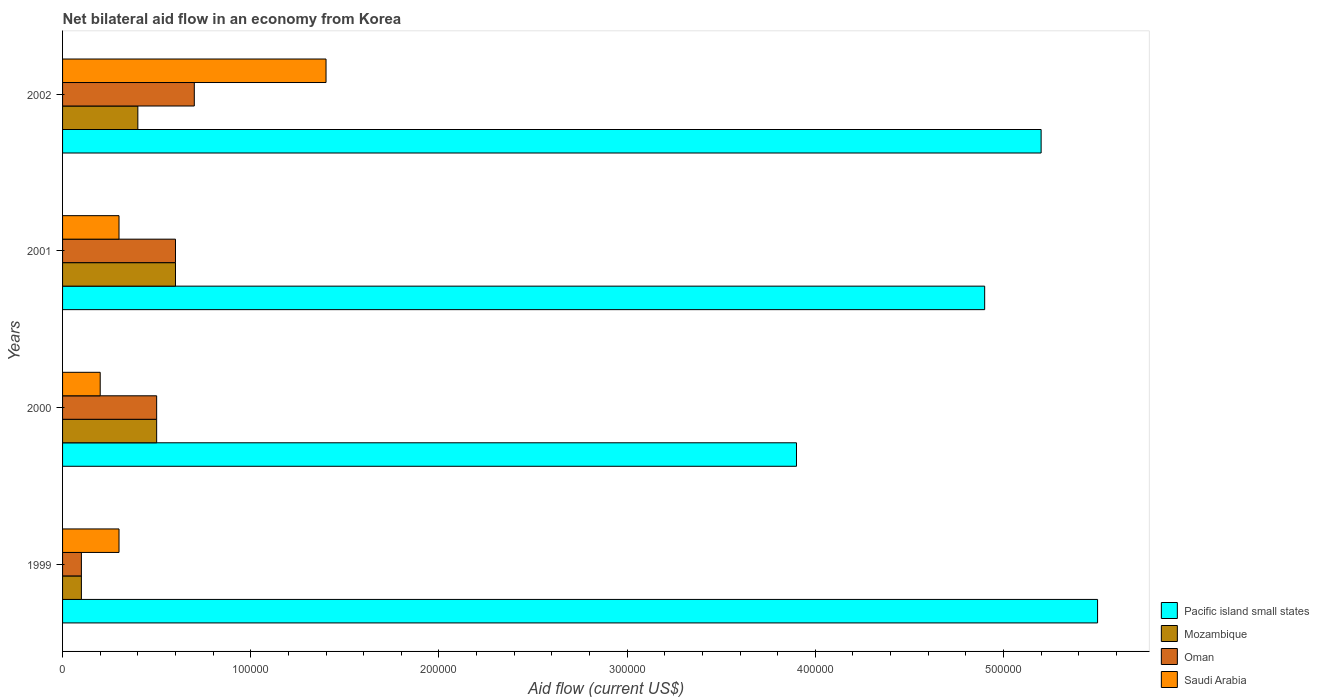How many different coloured bars are there?
Give a very brief answer. 4. How many groups of bars are there?
Provide a short and direct response. 4. In how many cases, is the number of bars for a given year not equal to the number of legend labels?
Offer a very short reply. 0. What is the net bilateral aid flow in Mozambique in 2001?
Make the answer very short. 6.00e+04. Across all years, what is the minimum net bilateral aid flow in Mozambique?
Make the answer very short. 10000. In which year was the net bilateral aid flow in Oman maximum?
Keep it short and to the point. 2002. What is the total net bilateral aid flow in Pacific island small states in the graph?
Your answer should be compact. 1.95e+06. What is the difference between the net bilateral aid flow in Mozambique in 1999 and that in 2001?
Make the answer very short. -5.00e+04. What is the average net bilateral aid flow in Pacific island small states per year?
Offer a very short reply. 4.88e+05. What is the ratio of the net bilateral aid flow in Oman in 1999 to that in 2002?
Your answer should be compact. 0.14. Is the difference between the net bilateral aid flow in Saudi Arabia in 1999 and 2000 greater than the difference between the net bilateral aid flow in Oman in 1999 and 2000?
Ensure brevity in your answer.  Yes. What is the difference between the highest and the lowest net bilateral aid flow in Saudi Arabia?
Keep it short and to the point. 1.20e+05. Is the sum of the net bilateral aid flow in Mozambique in 2000 and 2001 greater than the maximum net bilateral aid flow in Saudi Arabia across all years?
Your answer should be compact. No. Is it the case that in every year, the sum of the net bilateral aid flow in Saudi Arabia and net bilateral aid flow in Mozambique is greater than the sum of net bilateral aid flow in Pacific island small states and net bilateral aid flow in Oman?
Ensure brevity in your answer.  No. What does the 1st bar from the top in 1999 represents?
Provide a short and direct response. Saudi Arabia. What does the 3rd bar from the bottom in 2000 represents?
Give a very brief answer. Oman. How many bars are there?
Provide a short and direct response. 16. Are the values on the major ticks of X-axis written in scientific E-notation?
Provide a succinct answer. No. Where does the legend appear in the graph?
Give a very brief answer. Bottom right. What is the title of the graph?
Your response must be concise. Net bilateral aid flow in an economy from Korea. Does "Guyana" appear as one of the legend labels in the graph?
Offer a terse response. No. What is the label or title of the X-axis?
Make the answer very short. Aid flow (current US$). What is the Aid flow (current US$) of Oman in 2000?
Keep it short and to the point. 5.00e+04. What is the Aid flow (current US$) of Mozambique in 2001?
Give a very brief answer. 6.00e+04. What is the Aid flow (current US$) of Pacific island small states in 2002?
Offer a terse response. 5.20e+05. What is the Aid flow (current US$) in Mozambique in 2002?
Keep it short and to the point. 4.00e+04. What is the Aid flow (current US$) in Oman in 2002?
Provide a short and direct response. 7.00e+04. What is the Aid flow (current US$) of Saudi Arabia in 2002?
Provide a short and direct response. 1.40e+05. Across all years, what is the maximum Aid flow (current US$) in Mozambique?
Keep it short and to the point. 6.00e+04. Across all years, what is the maximum Aid flow (current US$) in Saudi Arabia?
Give a very brief answer. 1.40e+05. Across all years, what is the minimum Aid flow (current US$) in Mozambique?
Provide a short and direct response. 10000. What is the total Aid flow (current US$) of Pacific island small states in the graph?
Give a very brief answer. 1.95e+06. What is the difference between the Aid flow (current US$) of Pacific island small states in 1999 and that in 2000?
Provide a succinct answer. 1.60e+05. What is the difference between the Aid flow (current US$) of Oman in 1999 and that in 2000?
Offer a very short reply. -4.00e+04. What is the difference between the Aid flow (current US$) in Saudi Arabia in 1999 and that in 2000?
Provide a succinct answer. 10000. What is the difference between the Aid flow (current US$) of Pacific island small states in 1999 and that in 2001?
Offer a terse response. 6.00e+04. What is the difference between the Aid flow (current US$) in Mozambique in 1999 and that in 2001?
Your answer should be very brief. -5.00e+04. What is the difference between the Aid flow (current US$) in Oman in 1999 and that in 2001?
Ensure brevity in your answer.  -5.00e+04. What is the difference between the Aid flow (current US$) of Saudi Arabia in 1999 and that in 2001?
Keep it short and to the point. 0. What is the difference between the Aid flow (current US$) in Oman in 1999 and that in 2002?
Your answer should be compact. -6.00e+04. What is the difference between the Aid flow (current US$) of Pacific island small states in 2000 and that in 2001?
Your response must be concise. -1.00e+05. What is the difference between the Aid flow (current US$) of Oman in 2000 and that in 2001?
Offer a very short reply. -10000. What is the difference between the Aid flow (current US$) in Saudi Arabia in 2000 and that in 2001?
Offer a terse response. -10000. What is the difference between the Aid flow (current US$) of Pacific island small states in 2000 and that in 2002?
Your response must be concise. -1.30e+05. What is the difference between the Aid flow (current US$) of Mozambique in 2000 and that in 2002?
Provide a short and direct response. 10000. What is the difference between the Aid flow (current US$) of Oman in 2000 and that in 2002?
Keep it short and to the point. -2.00e+04. What is the difference between the Aid flow (current US$) in Pacific island small states in 2001 and that in 2002?
Ensure brevity in your answer.  -3.00e+04. What is the difference between the Aid flow (current US$) in Mozambique in 2001 and that in 2002?
Offer a terse response. 2.00e+04. What is the difference between the Aid flow (current US$) in Saudi Arabia in 2001 and that in 2002?
Offer a terse response. -1.10e+05. What is the difference between the Aid flow (current US$) in Pacific island small states in 1999 and the Aid flow (current US$) in Mozambique in 2000?
Keep it short and to the point. 5.00e+05. What is the difference between the Aid flow (current US$) of Pacific island small states in 1999 and the Aid flow (current US$) of Oman in 2000?
Your answer should be compact. 5.00e+05. What is the difference between the Aid flow (current US$) in Pacific island small states in 1999 and the Aid flow (current US$) in Saudi Arabia in 2000?
Provide a succinct answer. 5.30e+05. What is the difference between the Aid flow (current US$) of Mozambique in 1999 and the Aid flow (current US$) of Saudi Arabia in 2000?
Keep it short and to the point. -10000. What is the difference between the Aid flow (current US$) of Pacific island small states in 1999 and the Aid flow (current US$) of Mozambique in 2001?
Offer a terse response. 4.90e+05. What is the difference between the Aid flow (current US$) of Pacific island small states in 1999 and the Aid flow (current US$) of Saudi Arabia in 2001?
Keep it short and to the point. 5.20e+05. What is the difference between the Aid flow (current US$) of Pacific island small states in 1999 and the Aid flow (current US$) of Mozambique in 2002?
Your answer should be compact. 5.10e+05. What is the difference between the Aid flow (current US$) of Mozambique in 1999 and the Aid flow (current US$) of Saudi Arabia in 2002?
Offer a very short reply. -1.30e+05. What is the difference between the Aid flow (current US$) in Oman in 1999 and the Aid flow (current US$) in Saudi Arabia in 2002?
Make the answer very short. -1.30e+05. What is the difference between the Aid flow (current US$) of Pacific island small states in 2000 and the Aid flow (current US$) of Mozambique in 2001?
Offer a terse response. 3.30e+05. What is the difference between the Aid flow (current US$) in Pacific island small states in 2000 and the Aid flow (current US$) in Saudi Arabia in 2001?
Give a very brief answer. 3.60e+05. What is the difference between the Aid flow (current US$) in Pacific island small states in 2000 and the Aid flow (current US$) in Oman in 2002?
Your response must be concise. 3.20e+05. What is the difference between the Aid flow (current US$) in Mozambique in 2000 and the Aid flow (current US$) in Oman in 2002?
Offer a terse response. -2.00e+04. What is the difference between the Aid flow (current US$) in Mozambique in 2000 and the Aid flow (current US$) in Saudi Arabia in 2002?
Offer a terse response. -9.00e+04. What is the difference between the Aid flow (current US$) of Oman in 2000 and the Aid flow (current US$) of Saudi Arabia in 2002?
Offer a terse response. -9.00e+04. What is the difference between the Aid flow (current US$) of Pacific island small states in 2001 and the Aid flow (current US$) of Mozambique in 2002?
Make the answer very short. 4.50e+05. What is the difference between the Aid flow (current US$) in Pacific island small states in 2001 and the Aid flow (current US$) in Oman in 2002?
Your response must be concise. 4.20e+05. What is the difference between the Aid flow (current US$) of Pacific island small states in 2001 and the Aid flow (current US$) of Saudi Arabia in 2002?
Make the answer very short. 3.50e+05. What is the difference between the Aid flow (current US$) of Mozambique in 2001 and the Aid flow (current US$) of Oman in 2002?
Keep it short and to the point. -10000. What is the average Aid flow (current US$) of Pacific island small states per year?
Offer a terse response. 4.88e+05. What is the average Aid flow (current US$) in Mozambique per year?
Provide a short and direct response. 4.00e+04. What is the average Aid flow (current US$) in Oman per year?
Your response must be concise. 4.75e+04. What is the average Aid flow (current US$) in Saudi Arabia per year?
Give a very brief answer. 5.50e+04. In the year 1999, what is the difference between the Aid flow (current US$) of Pacific island small states and Aid flow (current US$) of Mozambique?
Provide a succinct answer. 5.40e+05. In the year 1999, what is the difference between the Aid flow (current US$) in Pacific island small states and Aid flow (current US$) in Oman?
Make the answer very short. 5.40e+05. In the year 1999, what is the difference between the Aid flow (current US$) in Pacific island small states and Aid flow (current US$) in Saudi Arabia?
Your answer should be very brief. 5.20e+05. In the year 2000, what is the difference between the Aid flow (current US$) of Pacific island small states and Aid flow (current US$) of Mozambique?
Provide a succinct answer. 3.40e+05. In the year 2000, what is the difference between the Aid flow (current US$) in Mozambique and Aid flow (current US$) in Oman?
Offer a terse response. 0. In the year 2000, what is the difference between the Aid flow (current US$) of Mozambique and Aid flow (current US$) of Saudi Arabia?
Your answer should be very brief. 3.00e+04. In the year 2001, what is the difference between the Aid flow (current US$) of Pacific island small states and Aid flow (current US$) of Mozambique?
Ensure brevity in your answer.  4.30e+05. In the year 2001, what is the difference between the Aid flow (current US$) in Oman and Aid flow (current US$) in Saudi Arabia?
Your answer should be compact. 3.00e+04. In the year 2002, what is the difference between the Aid flow (current US$) of Pacific island small states and Aid flow (current US$) of Mozambique?
Offer a very short reply. 4.80e+05. In the year 2002, what is the difference between the Aid flow (current US$) in Pacific island small states and Aid flow (current US$) in Oman?
Give a very brief answer. 4.50e+05. In the year 2002, what is the difference between the Aid flow (current US$) in Pacific island small states and Aid flow (current US$) in Saudi Arabia?
Provide a succinct answer. 3.80e+05. In the year 2002, what is the difference between the Aid flow (current US$) in Mozambique and Aid flow (current US$) in Oman?
Your answer should be compact. -3.00e+04. In the year 2002, what is the difference between the Aid flow (current US$) in Mozambique and Aid flow (current US$) in Saudi Arabia?
Your answer should be very brief. -1.00e+05. In the year 2002, what is the difference between the Aid flow (current US$) in Oman and Aid flow (current US$) in Saudi Arabia?
Offer a terse response. -7.00e+04. What is the ratio of the Aid flow (current US$) of Pacific island small states in 1999 to that in 2000?
Your answer should be compact. 1.41. What is the ratio of the Aid flow (current US$) in Saudi Arabia in 1999 to that in 2000?
Offer a terse response. 1.5. What is the ratio of the Aid flow (current US$) in Pacific island small states in 1999 to that in 2001?
Keep it short and to the point. 1.12. What is the ratio of the Aid flow (current US$) of Oman in 1999 to that in 2001?
Offer a very short reply. 0.17. What is the ratio of the Aid flow (current US$) of Pacific island small states in 1999 to that in 2002?
Make the answer very short. 1.06. What is the ratio of the Aid flow (current US$) in Oman in 1999 to that in 2002?
Ensure brevity in your answer.  0.14. What is the ratio of the Aid flow (current US$) in Saudi Arabia in 1999 to that in 2002?
Offer a terse response. 0.21. What is the ratio of the Aid flow (current US$) of Pacific island small states in 2000 to that in 2001?
Your answer should be compact. 0.8. What is the ratio of the Aid flow (current US$) of Mozambique in 2000 to that in 2001?
Your response must be concise. 0.83. What is the ratio of the Aid flow (current US$) of Saudi Arabia in 2000 to that in 2001?
Ensure brevity in your answer.  0.67. What is the ratio of the Aid flow (current US$) of Pacific island small states in 2000 to that in 2002?
Provide a succinct answer. 0.75. What is the ratio of the Aid flow (current US$) in Mozambique in 2000 to that in 2002?
Ensure brevity in your answer.  1.25. What is the ratio of the Aid flow (current US$) of Saudi Arabia in 2000 to that in 2002?
Ensure brevity in your answer.  0.14. What is the ratio of the Aid flow (current US$) of Pacific island small states in 2001 to that in 2002?
Offer a terse response. 0.94. What is the ratio of the Aid flow (current US$) of Oman in 2001 to that in 2002?
Your answer should be very brief. 0.86. What is the ratio of the Aid flow (current US$) in Saudi Arabia in 2001 to that in 2002?
Provide a succinct answer. 0.21. What is the difference between the highest and the second highest Aid flow (current US$) of Pacific island small states?
Your answer should be compact. 3.00e+04. What is the difference between the highest and the second highest Aid flow (current US$) in Oman?
Keep it short and to the point. 10000. What is the difference between the highest and the second highest Aid flow (current US$) of Saudi Arabia?
Make the answer very short. 1.10e+05. What is the difference between the highest and the lowest Aid flow (current US$) in Pacific island small states?
Provide a succinct answer. 1.60e+05. What is the difference between the highest and the lowest Aid flow (current US$) of Mozambique?
Make the answer very short. 5.00e+04. 